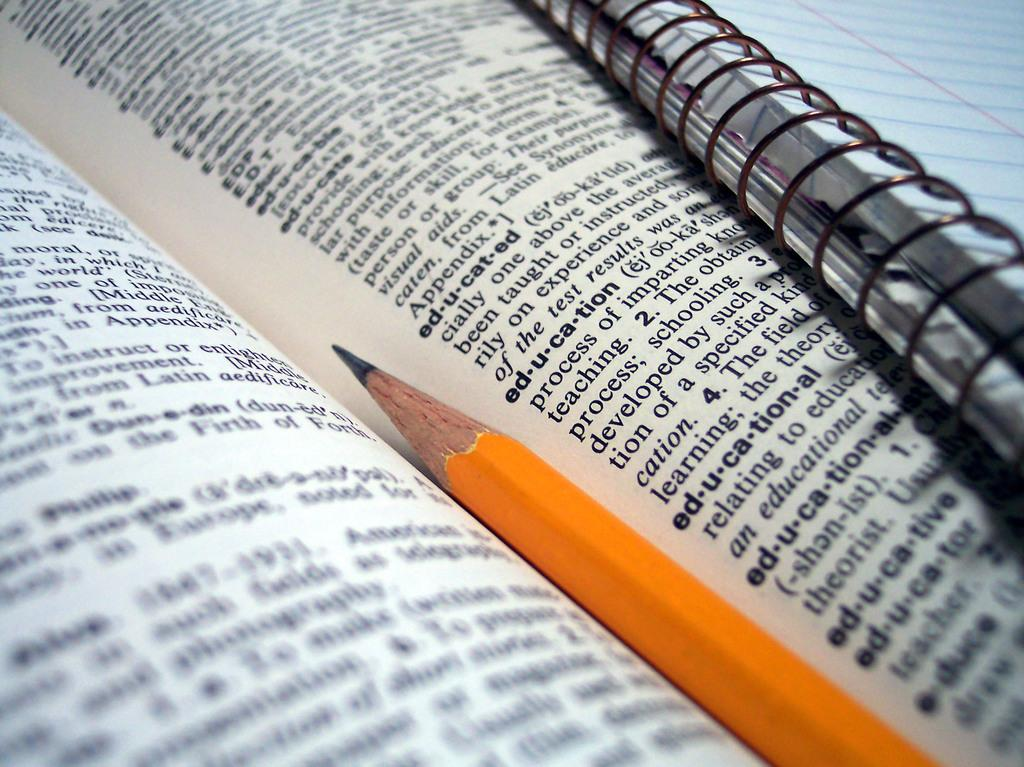What object can be seen in the image related to reading or learning? There is a book in the image. Can you describe what is on the book? Something is written on the book. What writing instrument is present in the image? There is a yellow pencil in the image. Are there any other books visible in the image? Yes, there is another book in the image. Where is the lettuce placed in the image? There is no lettuce present in the image. What type of quill is used for writing in the image? There is no quill present in the image; only a yellow pencil is visible. 